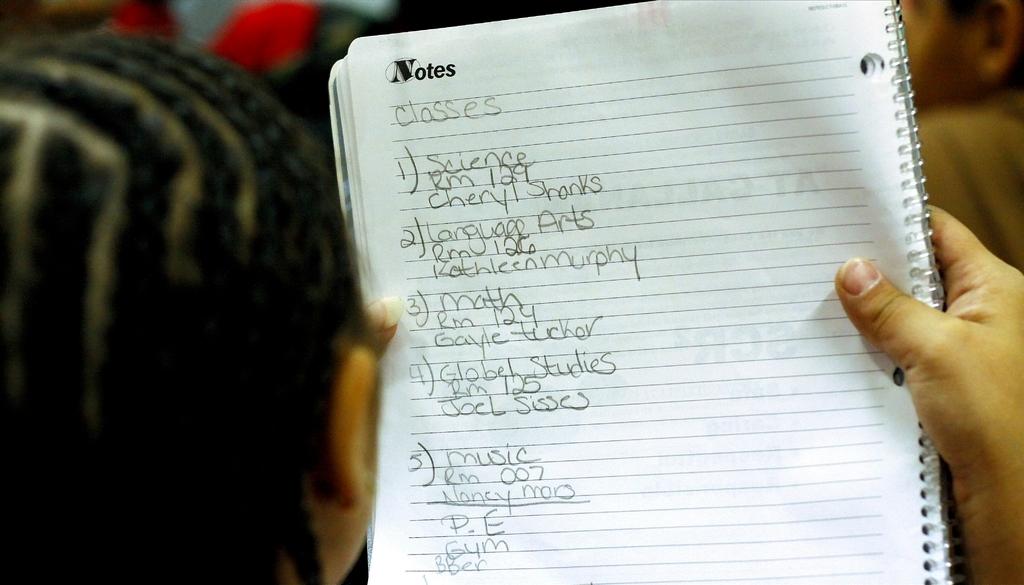Which classes are listed here?
Make the answer very short. Science, language arts, math, global studies, music. What was this list written in?
Ensure brevity in your answer.  English. 